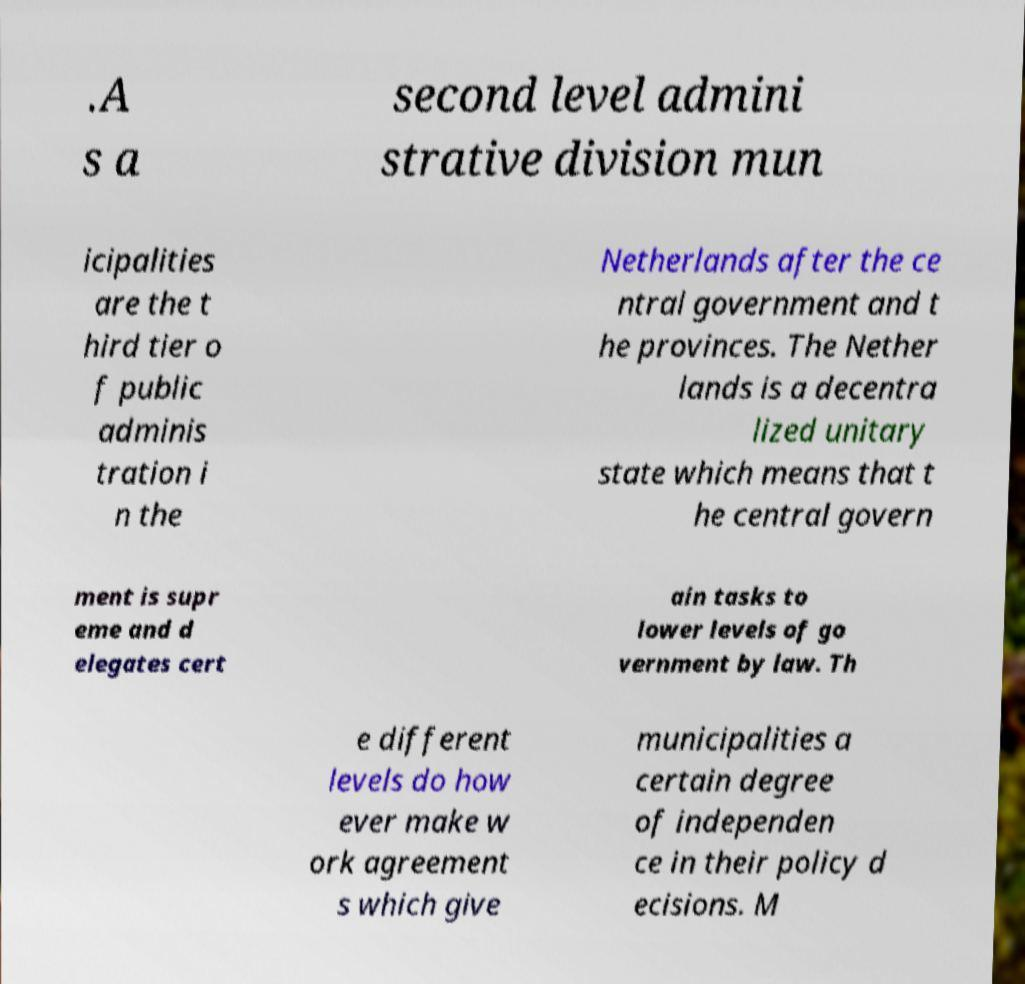What messages or text are displayed in this image? I need them in a readable, typed format. .A s a second level admini strative division mun icipalities are the t hird tier o f public adminis tration i n the Netherlands after the ce ntral government and t he provinces. The Nether lands is a decentra lized unitary state which means that t he central govern ment is supr eme and d elegates cert ain tasks to lower levels of go vernment by law. Th e different levels do how ever make w ork agreement s which give municipalities a certain degree of independen ce in their policy d ecisions. M 